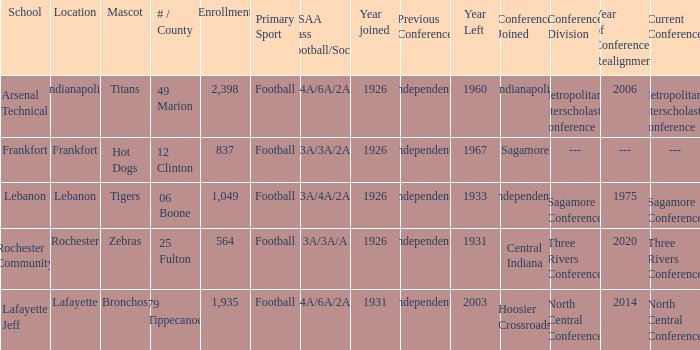What is the average enrollment that has hot dogs as the mascot, with a year joined later than 1926? None. 